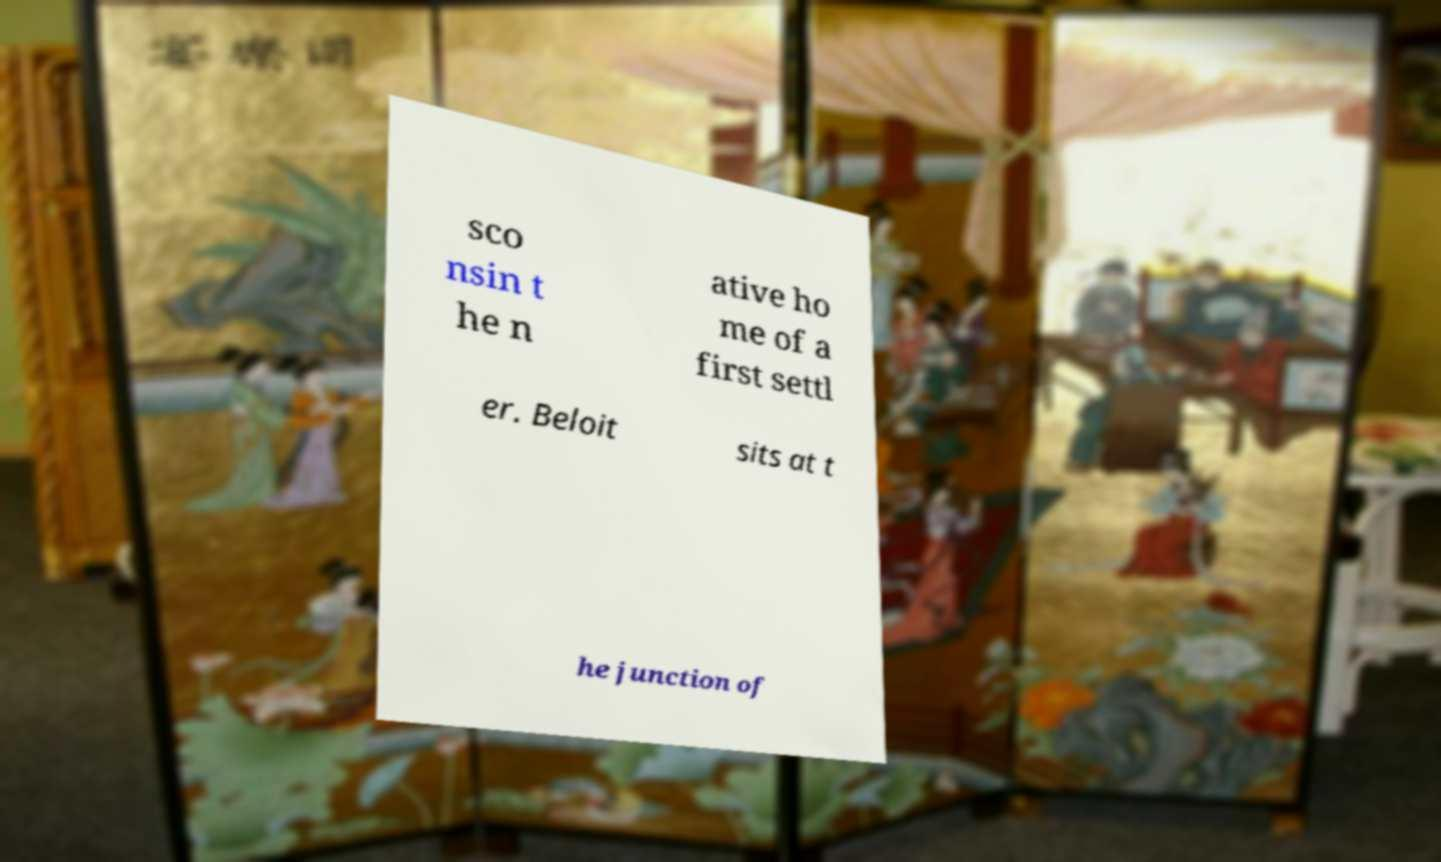Please identify and transcribe the text found in this image. sco nsin t he n ative ho me of a first settl er. Beloit sits at t he junction of 